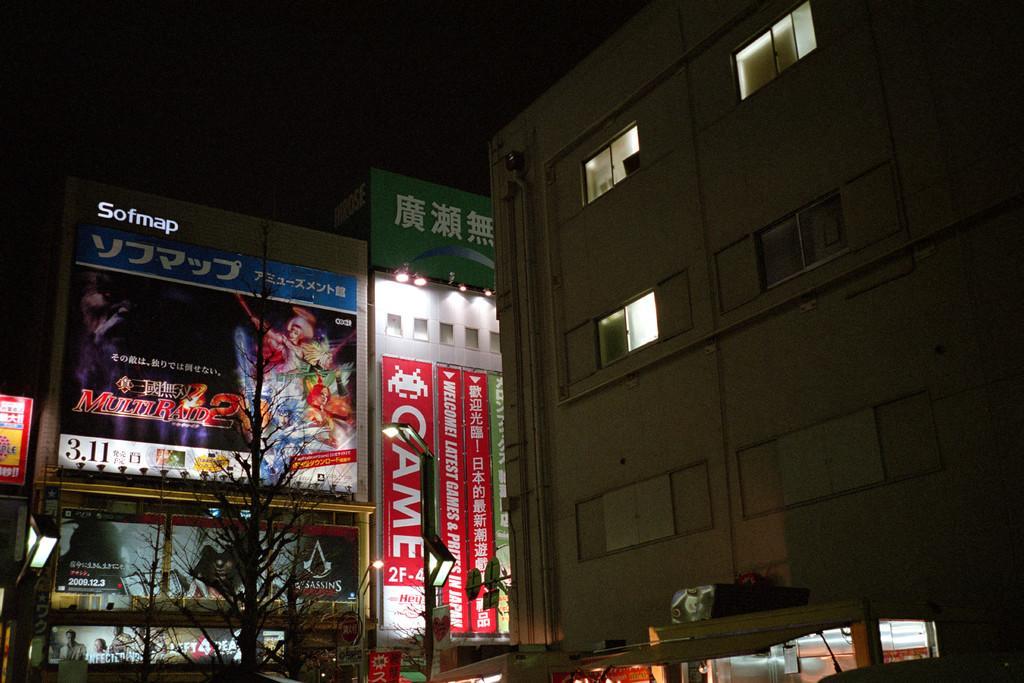Can you describe this image briefly? In the picture we can see a building with a window, and to the buildings we can also see some a hoardings and lights, and near to the building we can see a pole with a light. 